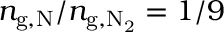<formula> <loc_0><loc_0><loc_500><loc_500>n _ { g , N } / n _ { g , N _ { 2 } } = 1 / 9</formula> 